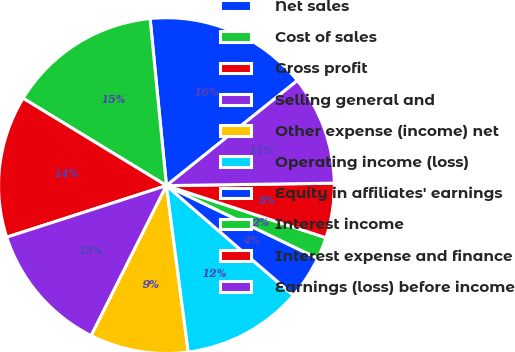Convert chart. <chart><loc_0><loc_0><loc_500><loc_500><pie_chart><fcel>Net sales<fcel>Cost of sales<fcel>Gross profit<fcel>Selling general and<fcel>Other expense (income) net<fcel>Operating income (loss)<fcel>Equity in affiliates' earnings<fcel>Interest income<fcel>Interest expense and finance<fcel>Earnings (loss) before income<nl><fcel>15.79%<fcel>14.74%<fcel>13.68%<fcel>12.63%<fcel>9.47%<fcel>11.58%<fcel>4.21%<fcel>2.11%<fcel>5.26%<fcel>10.53%<nl></chart> 